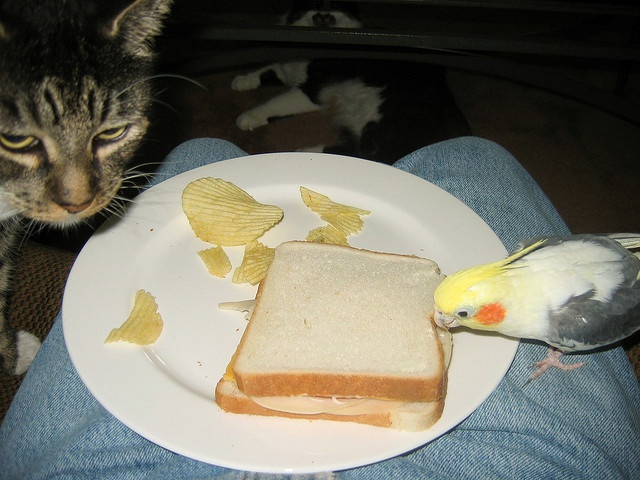Describe the objects in this image and their specific colors. I can see sandwich in black and tan tones, cat in black, gray, and tan tones, bird in black, khaki, gray, beige, and darkgray tones, and cat in black and gray tones in this image. 